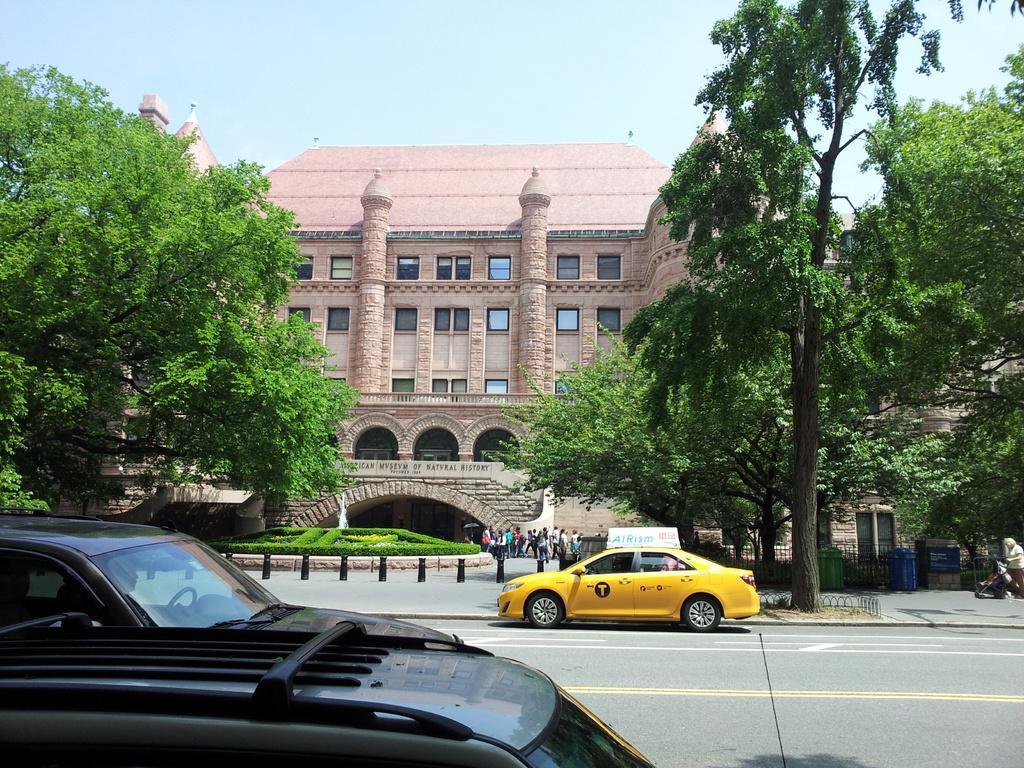In one or two sentences, can you explain what this image depicts? This image is taken outdoors. At the bottom of the image there is a road. On the left side of the image a car is parked on the road. The car is black in color. There is a tree with green leaves, stems and branches. At the top of the image there is the sky. On the right side of the image there are a few trees and a man is standing and he is holding a bike with his hand. There are two dustbins on the sidewalk and there is a board with a text on it. In the middle of the image there is a building with walls, windows, doors, pillars and there is a board with a text on it. There is a fountain with water and there are a few plants. Many people are walking on the floor and a car is moving on the road. 